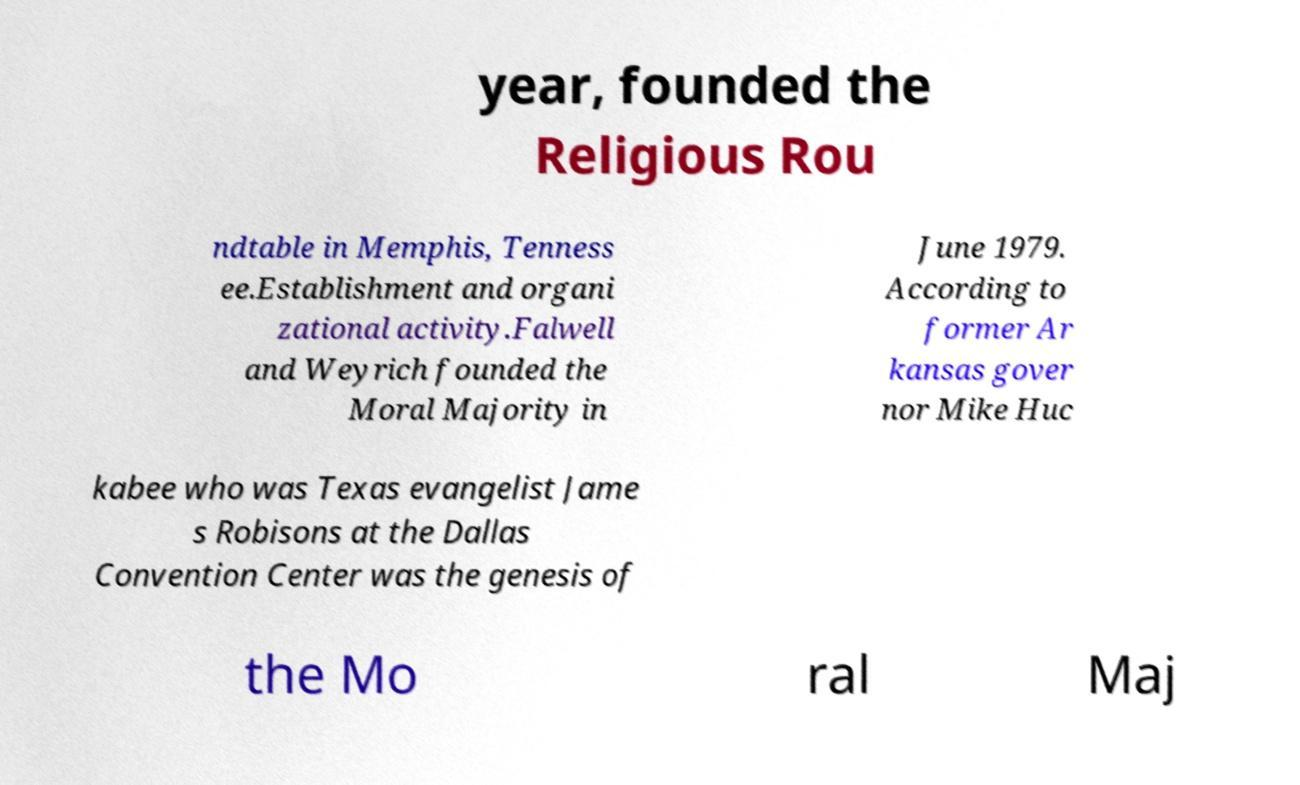Could you assist in decoding the text presented in this image and type it out clearly? year, founded the Religious Rou ndtable in Memphis, Tenness ee.Establishment and organi zational activity.Falwell and Weyrich founded the Moral Majority in June 1979. According to former Ar kansas gover nor Mike Huc kabee who was Texas evangelist Jame s Robisons at the Dallas Convention Center was the genesis of the Mo ral Maj 